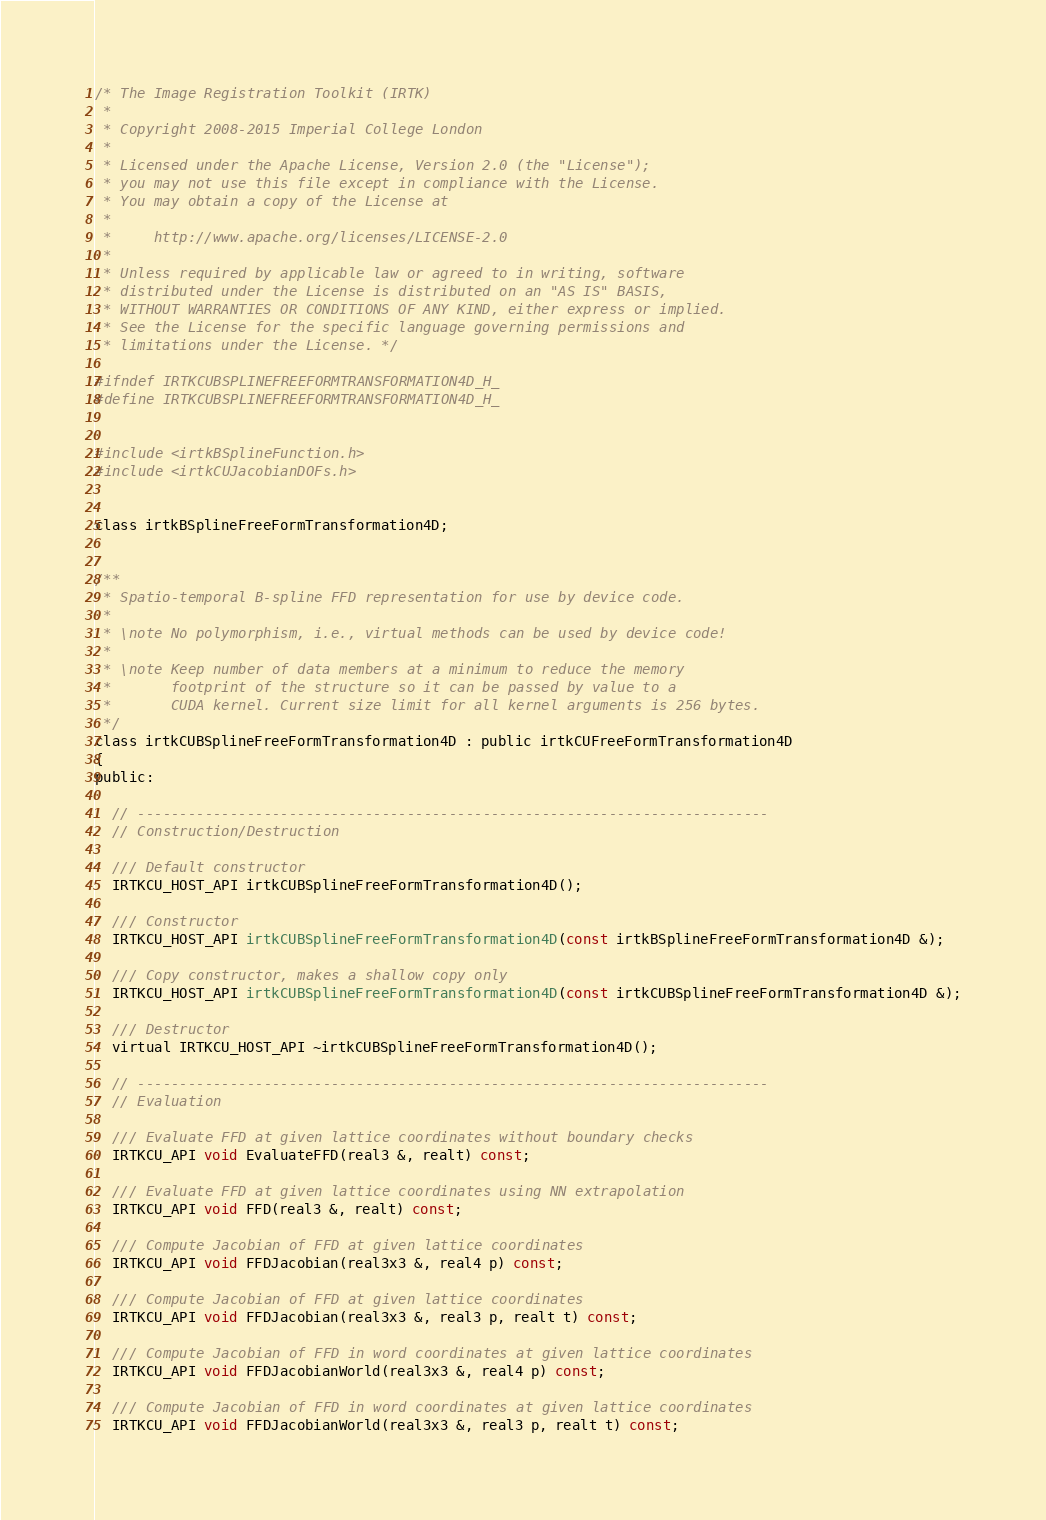Convert code to text. <code><loc_0><loc_0><loc_500><loc_500><_Cuda_>/* The Image Registration Toolkit (IRTK)
 *
 * Copyright 2008-2015 Imperial College London
 *
 * Licensed under the Apache License, Version 2.0 (the "License");
 * you may not use this file except in compliance with the License.
 * You may obtain a copy of the License at
 *
 *     http://www.apache.org/licenses/LICENSE-2.0
 *
 * Unless required by applicable law or agreed to in writing, software
 * distributed under the License is distributed on an "AS IS" BASIS,
 * WITHOUT WARRANTIES OR CONDITIONS OF ANY KIND, either express or implied.
 * See the License for the specific language governing permissions and
 * limitations under the License. */

#ifndef IRTKCUBSPLINEFREEFORMTRANSFORMATION4D_H_
#define IRTKCUBSPLINEFREEFORMTRANSFORMATION4D_H_


#include <irtkBSplineFunction.h>
#include <irtkCUJacobianDOFs.h>


class irtkBSplineFreeFormTransformation4D;


/**
 * Spatio-temporal B-spline FFD representation for use by device code.
 *
 * \note No polymorphism, i.e., virtual methods can be used by device code!
 *
 * \note Keep number of data members at a minimum to reduce the memory
 *       footprint of the structure so it can be passed by value to a
 *       CUDA kernel. Current size limit for all kernel arguments is 256 bytes.
 */
class irtkCUBSplineFreeFormTransformation4D : public irtkCUFreeFormTransformation4D
{
public:

  // ---------------------------------------------------------------------------
  // Construction/Destruction

  /// Default constructor
  IRTKCU_HOST_API irtkCUBSplineFreeFormTransformation4D();

  /// Constructor
  IRTKCU_HOST_API irtkCUBSplineFreeFormTransformation4D(const irtkBSplineFreeFormTransformation4D &);

  /// Copy constructor, makes a shallow copy only
  IRTKCU_HOST_API irtkCUBSplineFreeFormTransformation4D(const irtkCUBSplineFreeFormTransformation4D &);

  /// Destructor
  virtual IRTKCU_HOST_API ~irtkCUBSplineFreeFormTransformation4D();

  // ---------------------------------------------------------------------------
  // Evaluation

  /// Evaluate FFD at given lattice coordinates without boundary checks
  IRTKCU_API void EvaluateFFD(real3 &, realt) const;

  /// Evaluate FFD at given lattice coordinates using NN extrapolation
  IRTKCU_API void FFD(real3 &, realt) const;

  /// Compute Jacobian of FFD at given lattice coordinates
  IRTKCU_API void FFDJacobian(real3x3 &, real4 p) const;

  /// Compute Jacobian of FFD at given lattice coordinates
  IRTKCU_API void FFDJacobian(real3x3 &, real3 p, realt t) const;

  /// Compute Jacobian of FFD in word coordinates at given lattice coordinates
  IRTKCU_API void FFDJacobianWorld(real3x3 &, real4 p) const;

  /// Compute Jacobian of FFD in word coordinates at given lattice coordinates
  IRTKCU_API void FFDJacobianWorld(real3x3 &, real3 p, realt t) const;
</code> 